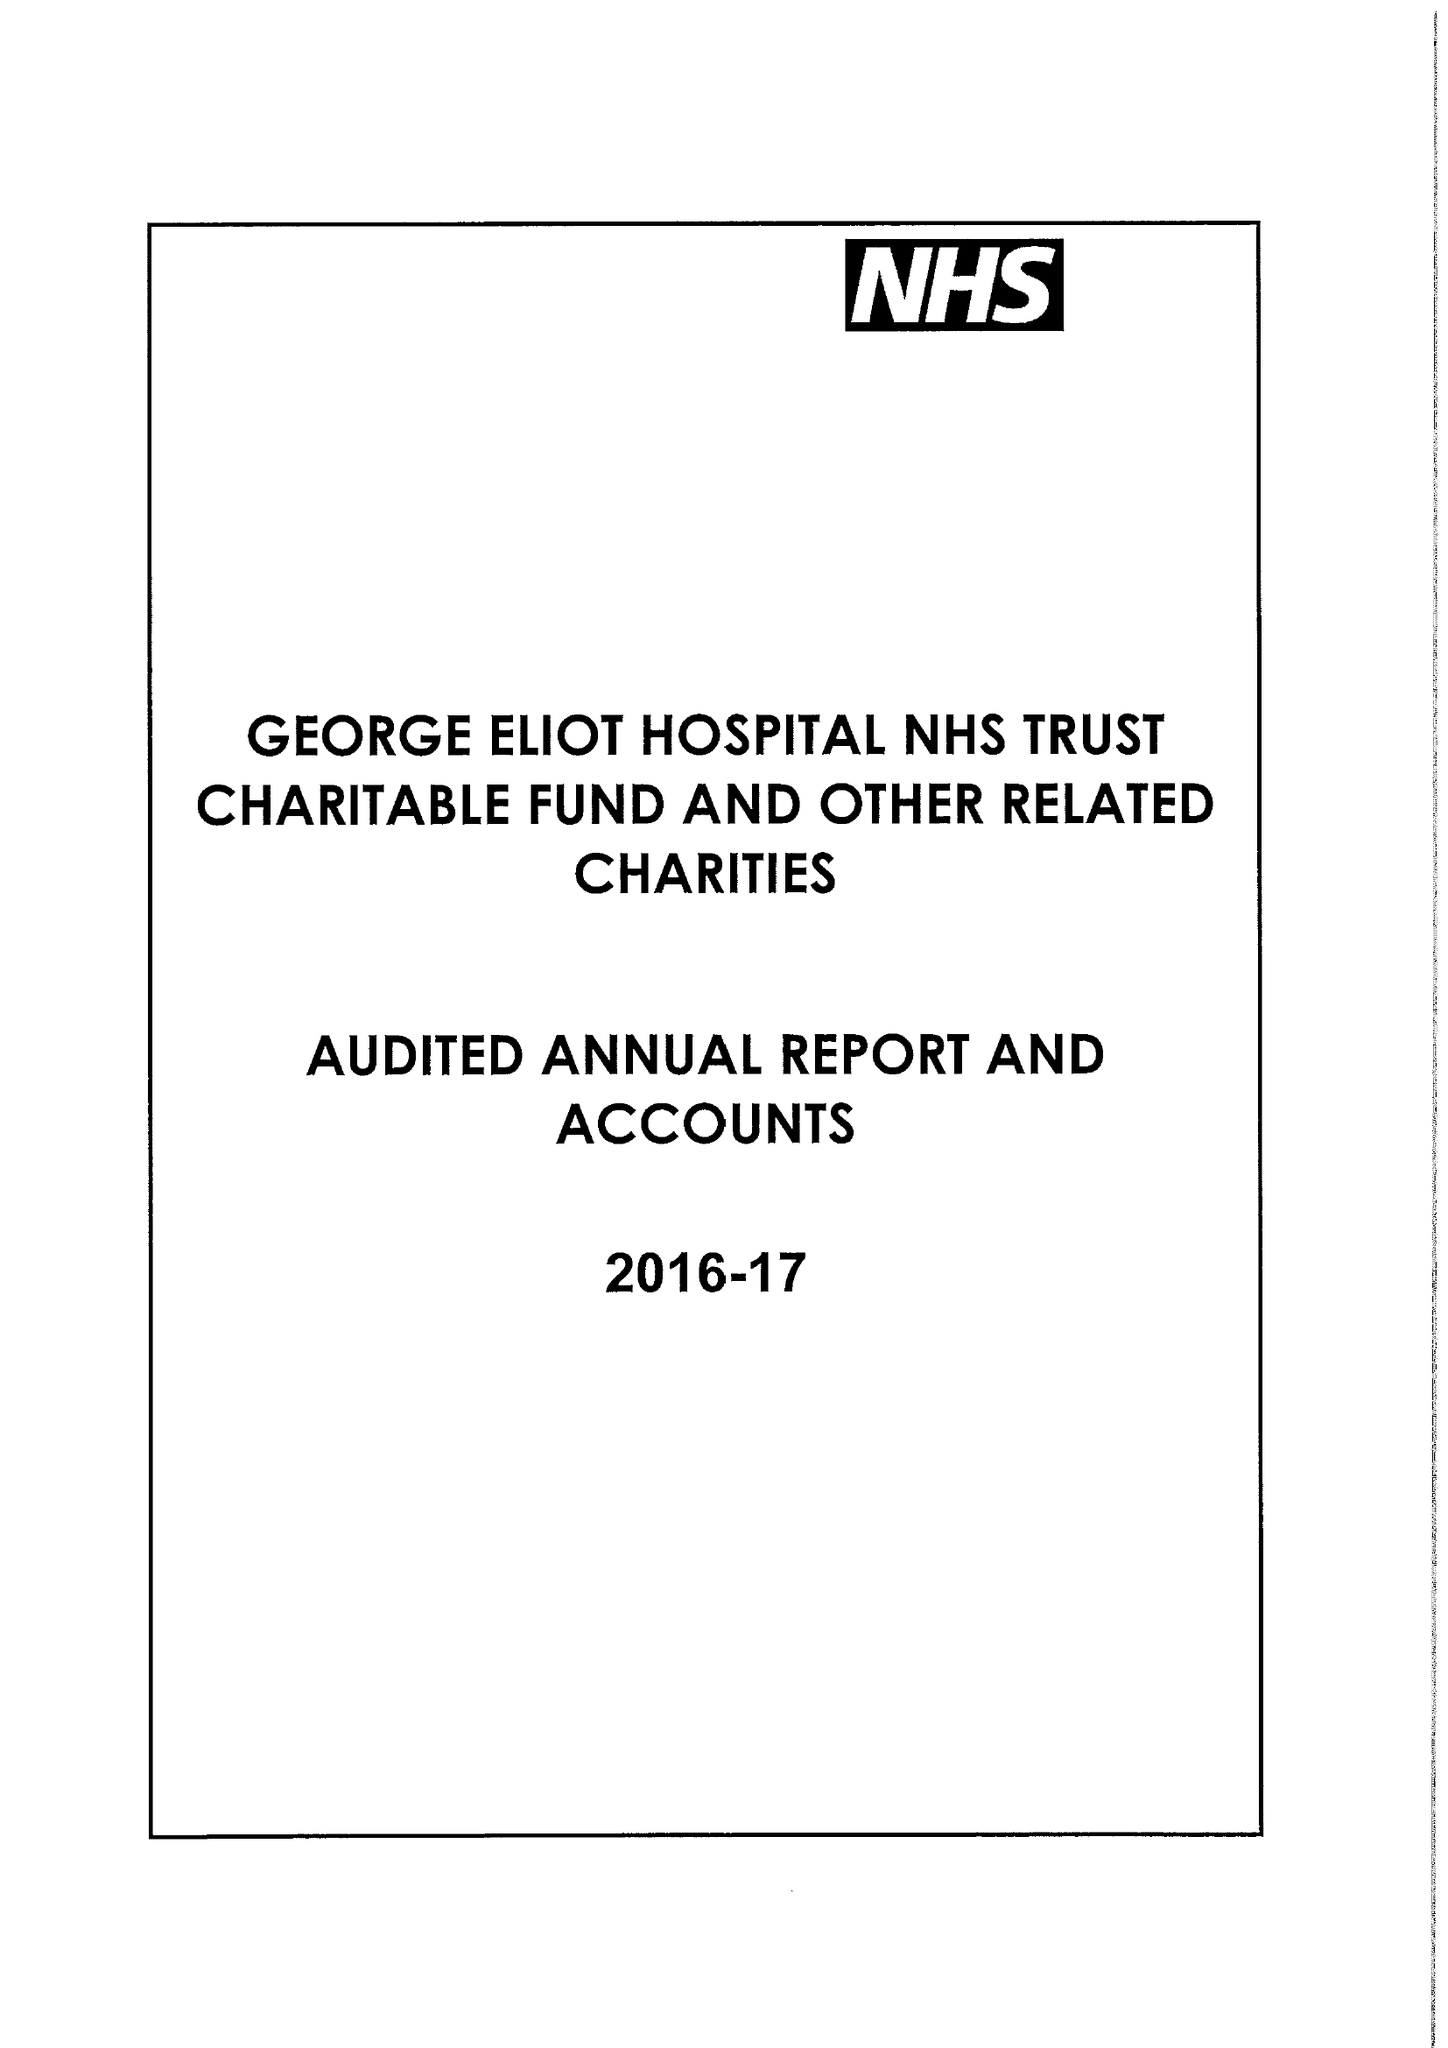What is the value for the address__street_line?
Answer the question using a single word or phrase. COLLEGE STREET 